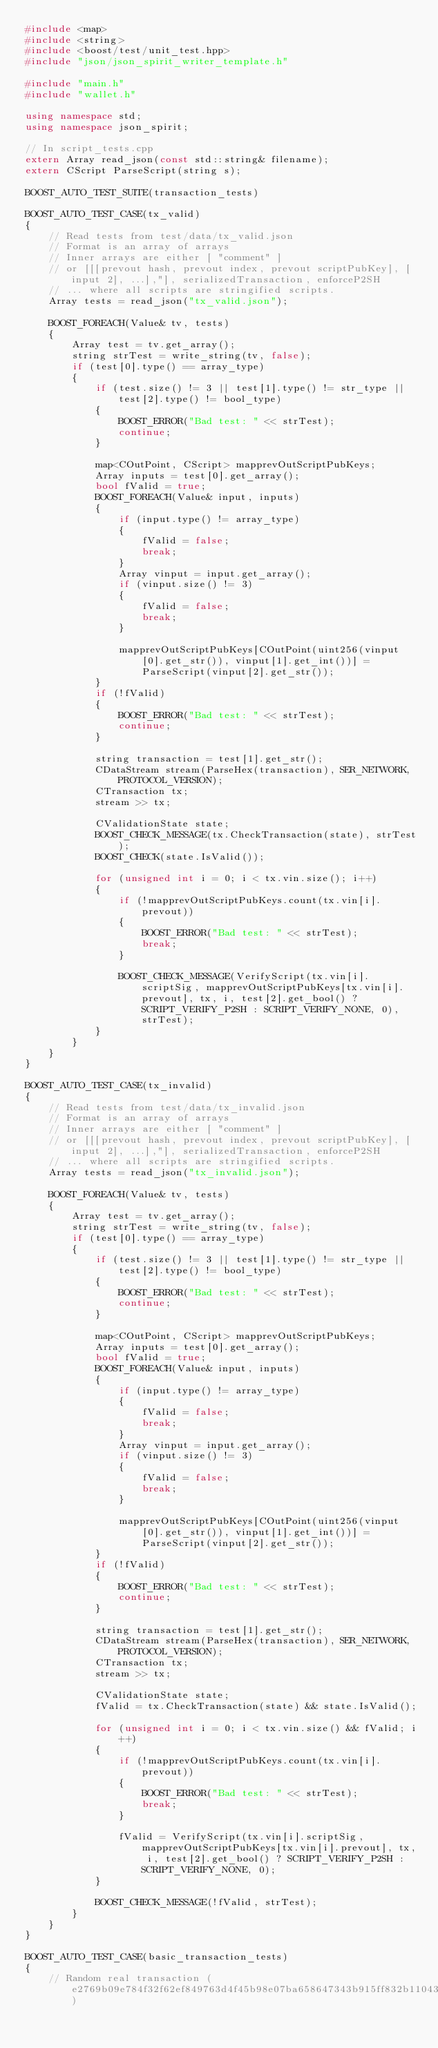Convert code to text. <code><loc_0><loc_0><loc_500><loc_500><_C++_>#include <map>
#include <string>
#include <boost/test/unit_test.hpp>
#include "json/json_spirit_writer_template.h"

#include "main.h"
#include "wallet.h"

using namespace std;
using namespace json_spirit;

// In script_tests.cpp
extern Array read_json(const std::string& filename);
extern CScript ParseScript(string s);

BOOST_AUTO_TEST_SUITE(transaction_tests)

BOOST_AUTO_TEST_CASE(tx_valid)
{
    // Read tests from test/data/tx_valid.json
    // Format is an array of arrays
    // Inner arrays are either [ "comment" ]
    // or [[[prevout hash, prevout index, prevout scriptPubKey], [input 2], ...],"], serializedTransaction, enforceP2SH
    // ... where all scripts are stringified scripts.
    Array tests = read_json("tx_valid.json");

    BOOST_FOREACH(Value& tv, tests)
    {
        Array test = tv.get_array();
        string strTest = write_string(tv, false);
        if (test[0].type() == array_type)
        {
            if (test.size() != 3 || test[1].type() != str_type || test[2].type() != bool_type)
            {
                BOOST_ERROR("Bad test: " << strTest);
                continue;
            }

            map<COutPoint, CScript> mapprevOutScriptPubKeys;
            Array inputs = test[0].get_array();
            bool fValid = true;
            BOOST_FOREACH(Value& input, inputs)
            {
                if (input.type() != array_type)
                {
                    fValid = false;
                    break;
                }
                Array vinput = input.get_array();
                if (vinput.size() != 3)
                {
                    fValid = false;
                    break;
                }

                mapprevOutScriptPubKeys[COutPoint(uint256(vinput[0].get_str()), vinput[1].get_int())] = ParseScript(vinput[2].get_str());
            }
            if (!fValid)
            {
                BOOST_ERROR("Bad test: " << strTest);
                continue;
            }

            string transaction = test[1].get_str();
            CDataStream stream(ParseHex(transaction), SER_NETWORK, PROTOCOL_VERSION);
            CTransaction tx;
            stream >> tx;

            CValidationState state;
            BOOST_CHECK_MESSAGE(tx.CheckTransaction(state), strTest);
            BOOST_CHECK(state.IsValid());

            for (unsigned int i = 0; i < tx.vin.size(); i++)
            {
                if (!mapprevOutScriptPubKeys.count(tx.vin[i].prevout))
                {
                    BOOST_ERROR("Bad test: " << strTest);
                    break;
                }

                BOOST_CHECK_MESSAGE(VerifyScript(tx.vin[i].scriptSig, mapprevOutScriptPubKeys[tx.vin[i].prevout], tx, i, test[2].get_bool() ? SCRIPT_VERIFY_P2SH : SCRIPT_VERIFY_NONE, 0), strTest);
            }
        }
    }
}

BOOST_AUTO_TEST_CASE(tx_invalid)
{
    // Read tests from test/data/tx_invalid.json
    // Format is an array of arrays
    // Inner arrays are either [ "comment" ]
    // or [[[prevout hash, prevout index, prevout scriptPubKey], [input 2], ...],"], serializedTransaction, enforceP2SH
    // ... where all scripts are stringified scripts.
    Array tests = read_json("tx_invalid.json");

    BOOST_FOREACH(Value& tv, tests)
    {
        Array test = tv.get_array();
        string strTest = write_string(tv, false);
        if (test[0].type() == array_type)
        {
            if (test.size() != 3 || test[1].type() != str_type || test[2].type() != bool_type)
            {
                BOOST_ERROR("Bad test: " << strTest);
                continue;
            }

            map<COutPoint, CScript> mapprevOutScriptPubKeys;
            Array inputs = test[0].get_array();
            bool fValid = true;
            BOOST_FOREACH(Value& input, inputs)
            {
                if (input.type() != array_type)
                {
                    fValid = false;
                    break;
                }
                Array vinput = input.get_array();
                if (vinput.size() != 3)
                {
                    fValid = false;
                    break;
                }

                mapprevOutScriptPubKeys[COutPoint(uint256(vinput[0].get_str()), vinput[1].get_int())] = ParseScript(vinput[2].get_str());
            }
            if (!fValid)
            {
                BOOST_ERROR("Bad test: " << strTest);
                continue;
            }

            string transaction = test[1].get_str();
            CDataStream stream(ParseHex(transaction), SER_NETWORK, PROTOCOL_VERSION);
            CTransaction tx;
            stream >> tx;

            CValidationState state;
            fValid = tx.CheckTransaction(state) && state.IsValid();

            for (unsigned int i = 0; i < tx.vin.size() && fValid; i++)
            {
                if (!mapprevOutScriptPubKeys.count(tx.vin[i].prevout))
                {
                    BOOST_ERROR("Bad test: " << strTest);
                    break;
                }

                fValid = VerifyScript(tx.vin[i].scriptSig, mapprevOutScriptPubKeys[tx.vin[i].prevout], tx, i, test[2].get_bool() ? SCRIPT_VERIFY_P2SH : SCRIPT_VERIFY_NONE, 0);
            }

            BOOST_CHECK_MESSAGE(!fValid, strTest);
        }
    }
}

BOOST_AUTO_TEST_CASE(basic_transaction_tests)
{
    // Random real transaction (e2769b09e784f32f62ef849763d4f45b98e07ba658647343b915ff832b110436)</code> 